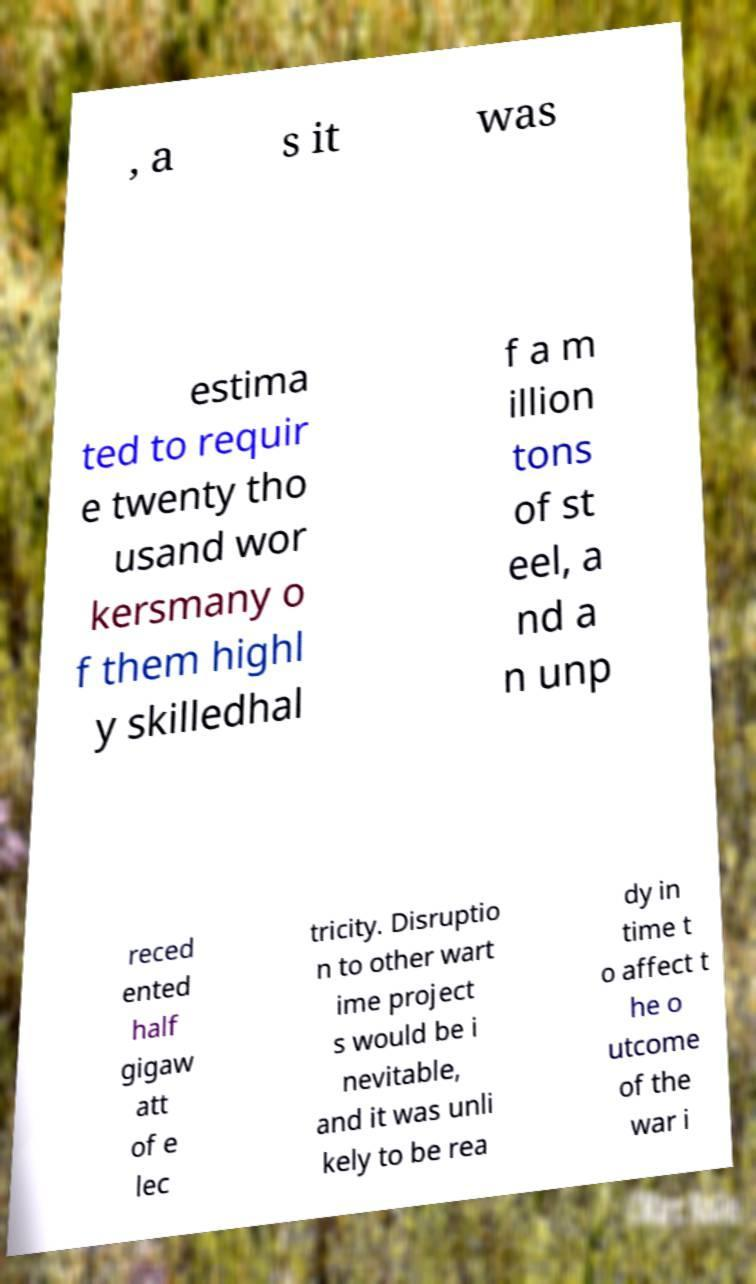Please identify and transcribe the text found in this image. , a s it was estima ted to requir e twenty tho usand wor kersmany o f them highl y skilledhal f a m illion tons of st eel, a nd a n unp reced ented half gigaw att of e lec tricity. Disruptio n to other wart ime project s would be i nevitable, and it was unli kely to be rea dy in time t o affect t he o utcome of the war i 